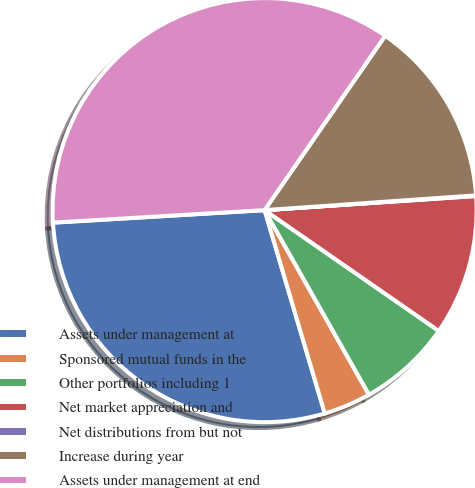<chart> <loc_0><loc_0><loc_500><loc_500><pie_chart><fcel>Assets under management at<fcel>Sponsored mutual funds in the<fcel>Other portfolios including 1<fcel>Net market appreciation and<fcel>Net distributions from but not<fcel>Increase during year<fcel>Assets under management at end<nl><fcel>28.64%<fcel>3.61%<fcel>7.16%<fcel>10.71%<fcel>0.05%<fcel>14.26%<fcel>35.57%<nl></chart> 